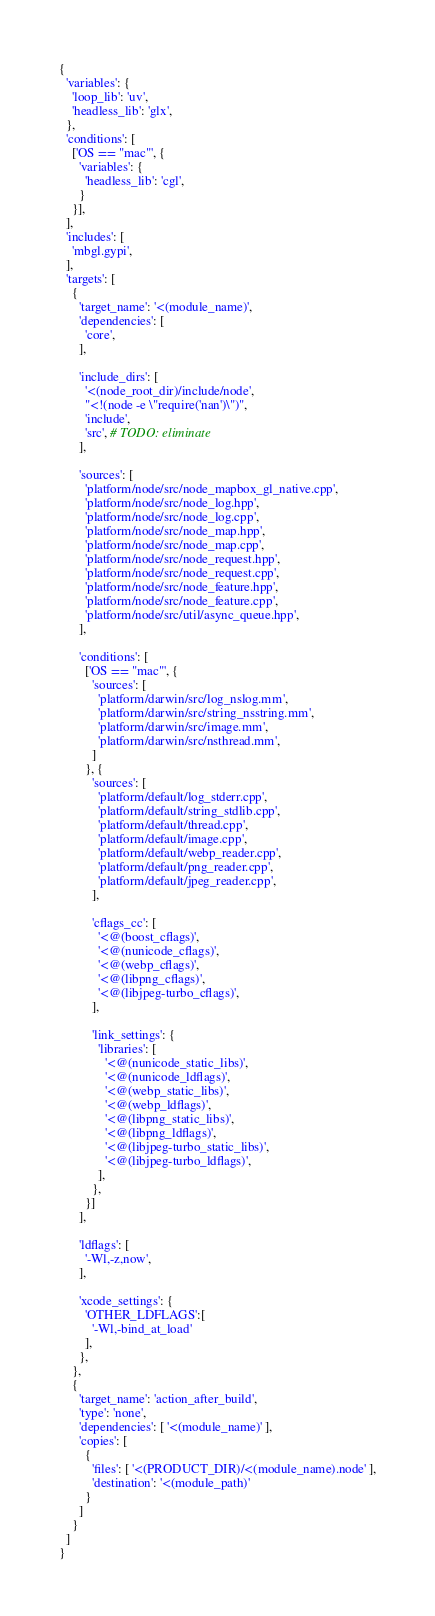Convert code to text. <code><loc_0><loc_0><loc_500><loc_500><_Python_>{
  'variables': {
    'loop_lib': 'uv',
    'headless_lib': 'glx',
  },
  'conditions': [
    ['OS == "mac"', {
      'variables': {
        'headless_lib': 'cgl',
      }
    }],
  ],
  'includes': [
    'mbgl.gypi',
  ],
  'targets': [
    {
      'target_name': '<(module_name)',
      'dependencies': [
        'core',
      ],

      'include_dirs': [
        '<(node_root_dir)/include/node',
        "<!(node -e \"require('nan')\")",
        'include',
        'src', # TODO: eliminate
      ],

      'sources': [
        'platform/node/src/node_mapbox_gl_native.cpp',
        'platform/node/src/node_log.hpp',
        'platform/node/src/node_log.cpp',
        'platform/node/src/node_map.hpp',
        'platform/node/src/node_map.cpp',
        'platform/node/src/node_request.hpp',
        'platform/node/src/node_request.cpp',
        'platform/node/src/node_feature.hpp',
        'platform/node/src/node_feature.cpp',
        'platform/node/src/util/async_queue.hpp',
      ],

      'conditions': [
        ['OS == "mac"', {
          'sources': [
            'platform/darwin/src/log_nslog.mm',
            'platform/darwin/src/string_nsstring.mm',
            'platform/darwin/src/image.mm',
            'platform/darwin/src/nsthread.mm',
          ]
        }, {
          'sources': [
            'platform/default/log_stderr.cpp',
            'platform/default/string_stdlib.cpp',
            'platform/default/thread.cpp',
            'platform/default/image.cpp',
            'platform/default/webp_reader.cpp',
            'platform/default/png_reader.cpp',
            'platform/default/jpeg_reader.cpp',
          ],

          'cflags_cc': [
            '<@(boost_cflags)',
            '<@(nunicode_cflags)',
            '<@(webp_cflags)',
            '<@(libpng_cflags)',
            '<@(libjpeg-turbo_cflags)',
          ],

          'link_settings': {
            'libraries': [
              '<@(nunicode_static_libs)',
              '<@(nunicode_ldflags)',
              '<@(webp_static_libs)',
              '<@(webp_ldflags)',
              '<@(libpng_static_libs)',
              '<@(libpng_ldflags)',
              '<@(libjpeg-turbo_static_libs)',
              '<@(libjpeg-turbo_ldflags)',
            ],
          },
        }]
      ],

      'ldflags': [
        '-Wl,-z,now',
      ],

      'xcode_settings': {
        'OTHER_LDFLAGS':[
          '-Wl,-bind_at_load'
        ],
      },
    },
    {
      'target_name': 'action_after_build',
      'type': 'none',
      'dependencies': [ '<(module_name)' ],
      'copies': [
        {
          'files': [ '<(PRODUCT_DIR)/<(module_name).node' ],
          'destination': '<(module_path)'
        }
      ]
    }
  ]
}
</code> 